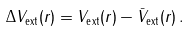Convert formula to latex. <formula><loc_0><loc_0><loc_500><loc_500>\Delta V _ { \text {ext} } ( { r } ) = V _ { \text {ext} } ( { r } ) - \bar { V } _ { \text {ext} } ( { r } ) \, .</formula> 